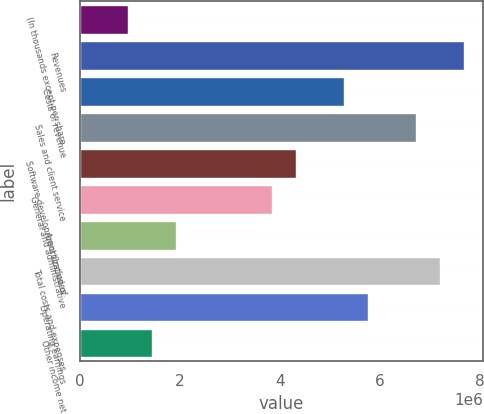<chart> <loc_0><loc_0><loc_500><loc_500><bar_chart><fcel>(In thousands except per share<fcel>Revenues<fcel>Costs of revenue<fcel>Sales and client service<fcel>Software development (Includes<fcel>General and administrative<fcel>Amortization of<fcel>Total costs and expenses<fcel>Operating earnings<fcel>Other income net<nl><fcel>959296<fcel>7.67436e+06<fcel>5.27612e+06<fcel>6.71506e+06<fcel>4.31683e+06<fcel>3.83718e+06<fcel>1.91859e+06<fcel>7.19471e+06<fcel>5.75577e+06<fcel>1.43894e+06<nl></chart> 